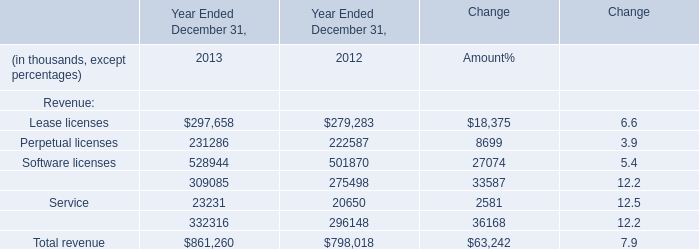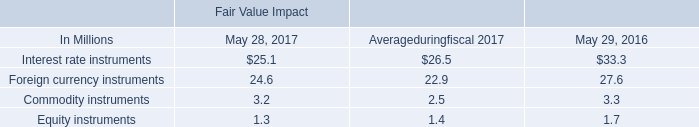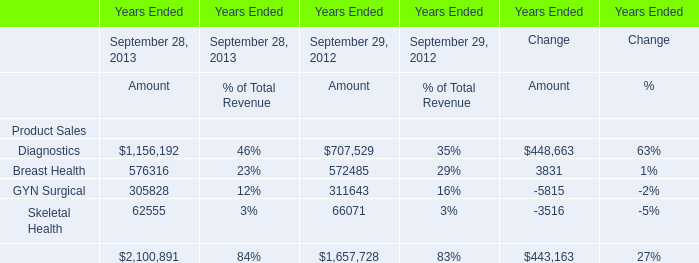What's the total amount of Total revenue excluding Lease licenses and Perpetual licenses in 2013? (in thousand) 
Computations: (861260 - 528944)
Answer: 332316.0. 